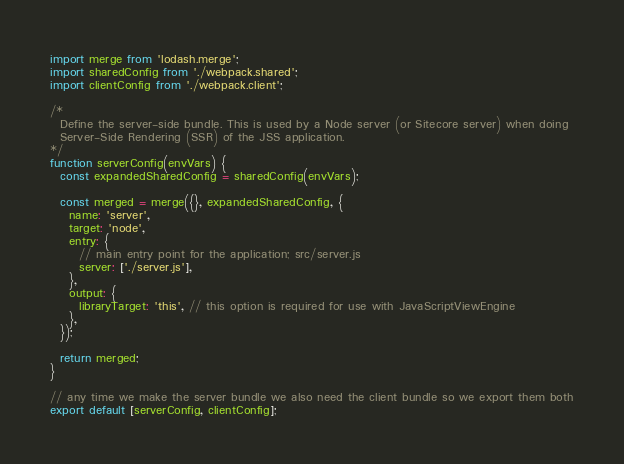<code> <loc_0><loc_0><loc_500><loc_500><_JavaScript_>import merge from 'lodash.merge';
import sharedConfig from './webpack.shared';
import clientConfig from './webpack.client';

/*
  Define the server-side bundle. This is used by a Node server (or Sitecore server) when doing
  Server-Side Rendering (SSR) of the JSS application.
*/
function serverConfig(envVars) {
  const expandedSharedConfig = sharedConfig(envVars);

  const merged = merge({}, expandedSharedConfig, {
    name: 'server',
    target: 'node',
    entry: {
      // main entry point for the application; src/server.js
      server: ['./server.js'],
    },
    output: {
      libraryTarget: 'this', // this option is required for use with JavaScriptViewEngine
    },
  });

  return merged;
}

// any time we make the server bundle we also need the client bundle so we export them both
export default [serverConfig, clientConfig];
</code> 